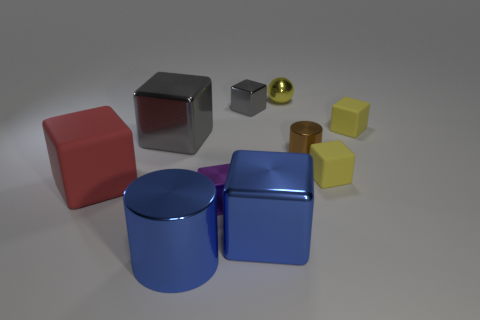Subtract all large blue cubes. How many cubes are left? 6 Subtract all gray blocks. How many blocks are left? 5 Subtract all red blocks. Subtract all gray cylinders. How many blocks are left? 6 Subtract all balls. How many objects are left? 9 Subtract all small yellow objects. Subtract all tiny purple blocks. How many objects are left? 6 Add 4 tiny metal balls. How many tiny metal balls are left? 5 Add 7 brown metallic cylinders. How many brown metallic cylinders exist? 8 Subtract 1 yellow balls. How many objects are left? 9 